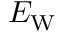Convert formula to latex. <formula><loc_0><loc_0><loc_500><loc_500>E _ { W }</formula> 